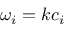<formula> <loc_0><loc_0><loc_500><loc_500>\omega _ { i } = k c _ { i }</formula> 